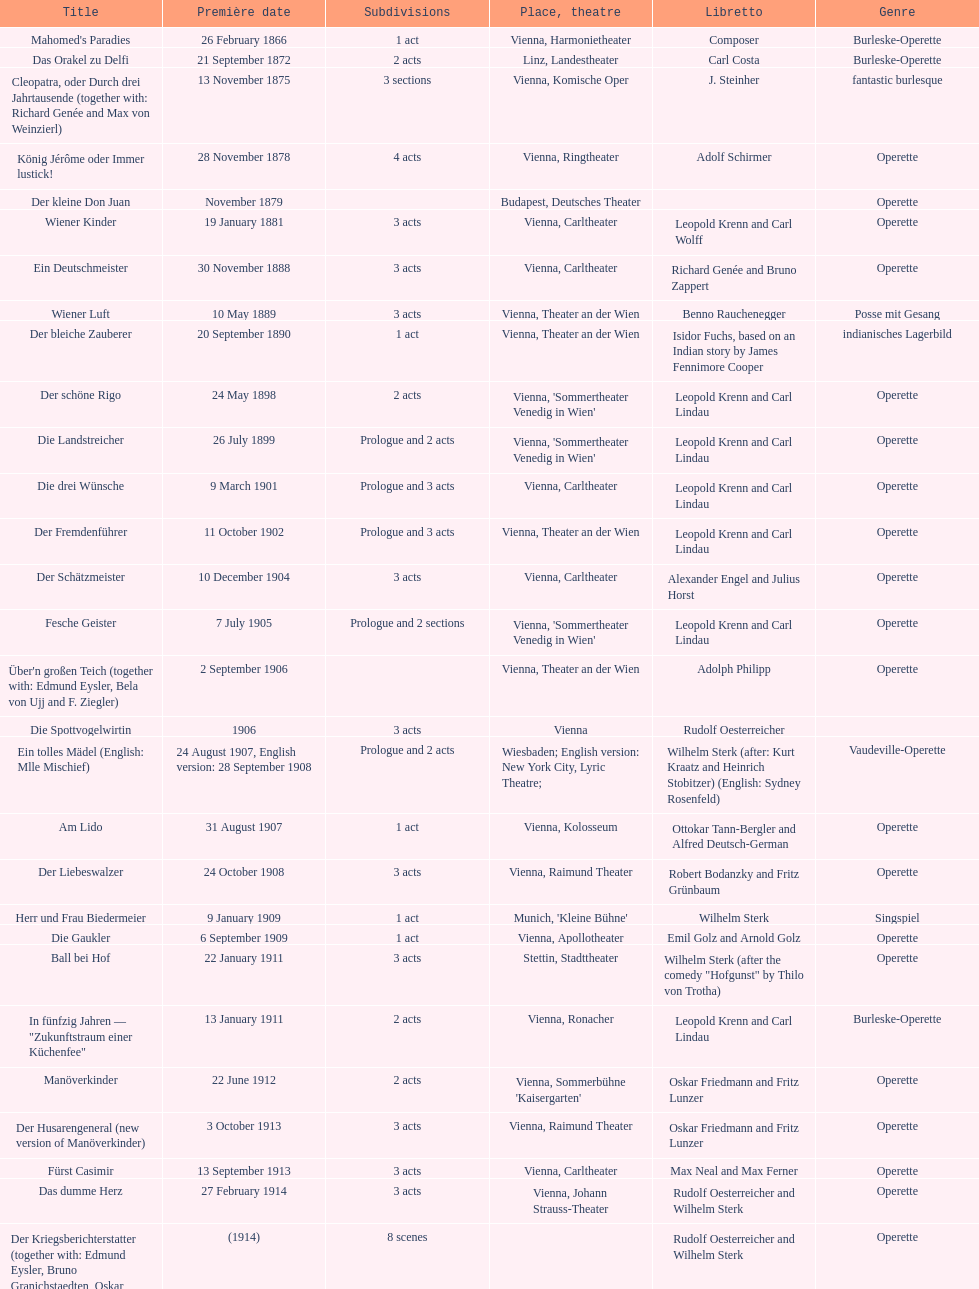How many number of 1 acts were there? 5. 